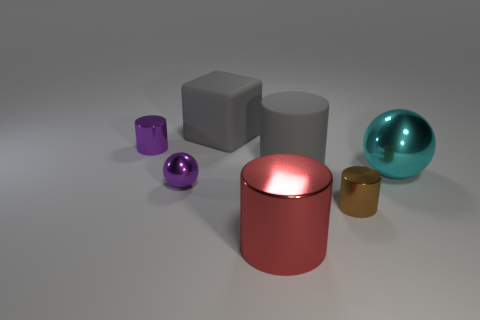Can you guess what material each object might be made from? The red canister and the cyan sphere could be made of polished metal due to their reflective qualities. The purple sphere and the cube have a matte surface, suggesting they might be made of plastic or painted with a non-glossy paint. The small canister's golden color and shine might indicate a metallic finish as well. 